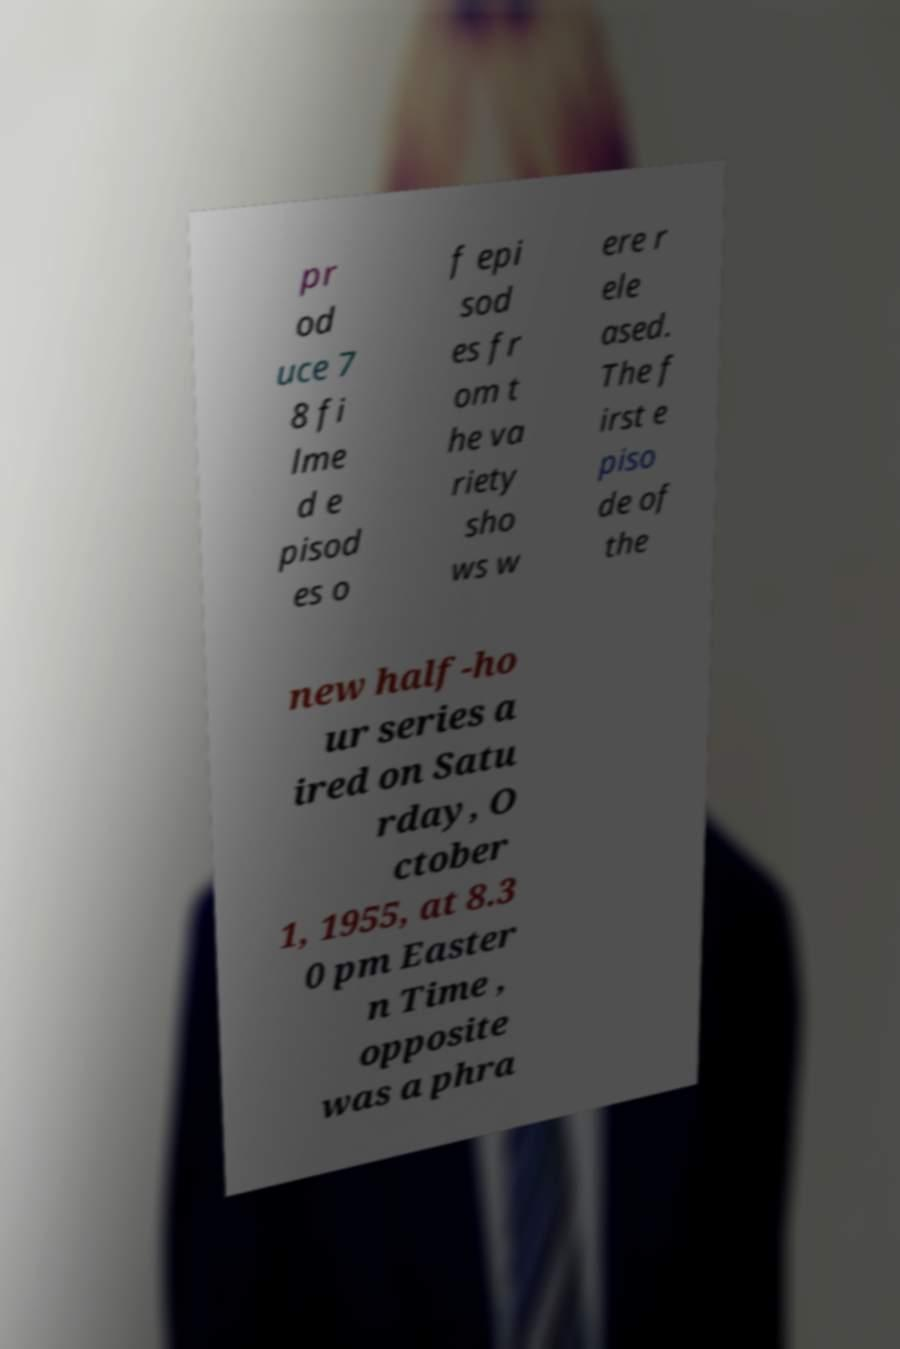What messages or text are displayed in this image? I need them in a readable, typed format. pr od uce 7 8 fi lme d e pisod es o f epi sod es fr om t he va riety sho ws w ere r ele ased. The f irst e piso de of the new half-ho ur series a ired on Satu rday, O ctober 1, 1955, at 8.3 0 pm Easter n Time , opposite was a phra 